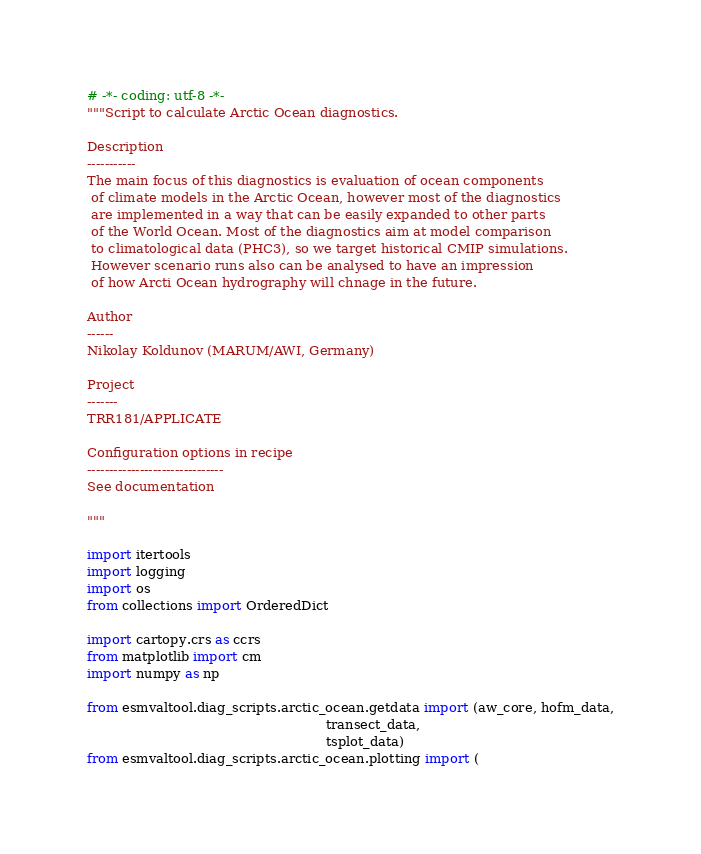Convert code to text. <code><loc_0><loc_0><loc_500><loc_500><_Python_># -*- coding: utf-8 -*-
"""Script to calculate Arctic Ocean diagnostics.

Description
-----------
The main focus of this diagnostics is evaluation of ocean components
 of climate models in the Arctic Ocean, however most of the diagnostics
 are implemented in a way that can be easily expanded to other parts
 of the World Ocean. Most of the diagnostics aim at model comparison
 to climatological data (PHC3), so we target historical CMIP simulations.
 However scenario runs also can be analysed to have an impression
 of how Arcti Ocean hydrography will chnage in the future.

Author
------
Nikolay Koldunov (MARUM/AWI, Germany)

Project
-------
TRR181/APPLICATE

Configuration options in recipe
-------------------------------
See documentation

"""

import itertools
import logging
import os
from collections import OrderedDict

import cartopy.crs as ccrs
from matplotlib import cm
import numpy as np

from esmvaltool.diag_scripts.arctic_ocean.getdata import (aw_core, hofm_data,
                                                          transect_data,
                                                          tsplot_data)
from esmvaltool.diag_scripts.arctic_ocean.plotting import (</code> 